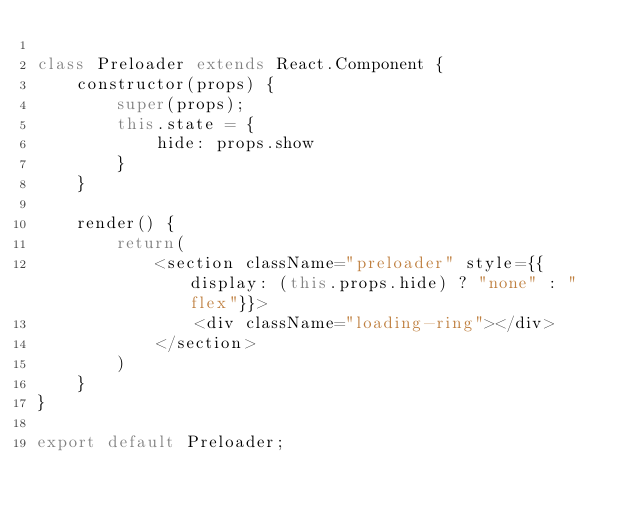Convert code to text. <code><loc_0><loc_0><loc_500><loc_500><_JavaScript_>
class Preloader extends React.Component {
    constructor(props) {
        super(props);
        this.state = {
            hide: props.show
        }
    }

    render() {
        return(
            <section className="preloader" style={{display: (this.props.hide) ? "none" : "flex"}}>
                <div className="loading-ring"></div>
            </section>
        )
    }
}

export default Preloader;</code> 